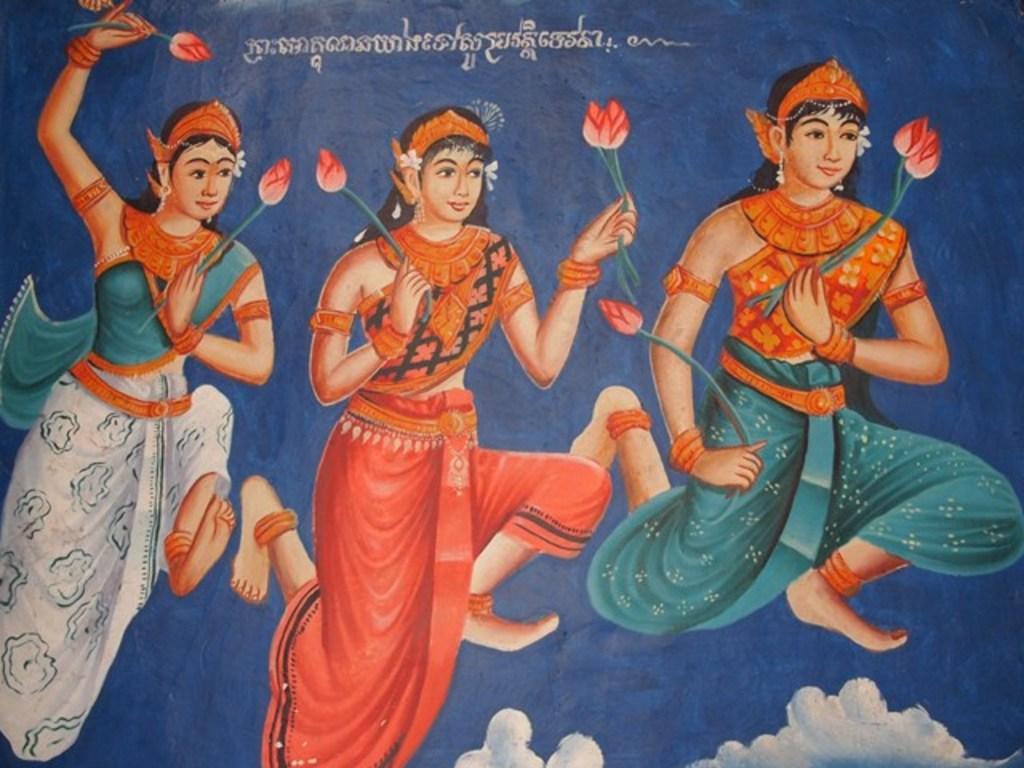Could you give a brief overview of what you see in this image? In this picture we can see few paintings. 